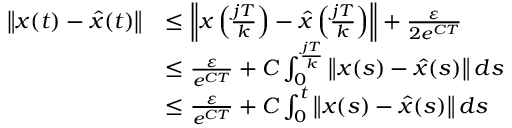Convert formula to latex. <formula><loc_0><loc_0><loc_500><loc_500>\begin{array} { r l } { \left \| x ( t ) - \hat { x } ( t ) \right \| } & { \leq \left \| x \left ( \frac { j T } { k } \right ) - \hat { x } \left ( \frac { j T } { k } \right ) \right \| + \frac { \varepsilon } { 2 e ^ { C T } } } \\ & { \leq \frac { \varepsilon } { e ^ { C T } } + C \int _ { 0 } ^ { \frac { j T } { k } } \left \| x ( s ) - \hat { x } ( s ) \right \| d s } \\ & { \leq \frac { \varepsilon } { e ^ { C T } } + C \int _ { 0 } ^ { t } \left \| x ( s ) - \hat { x } ( s ) \right \| d s } \end{array}</formula> 